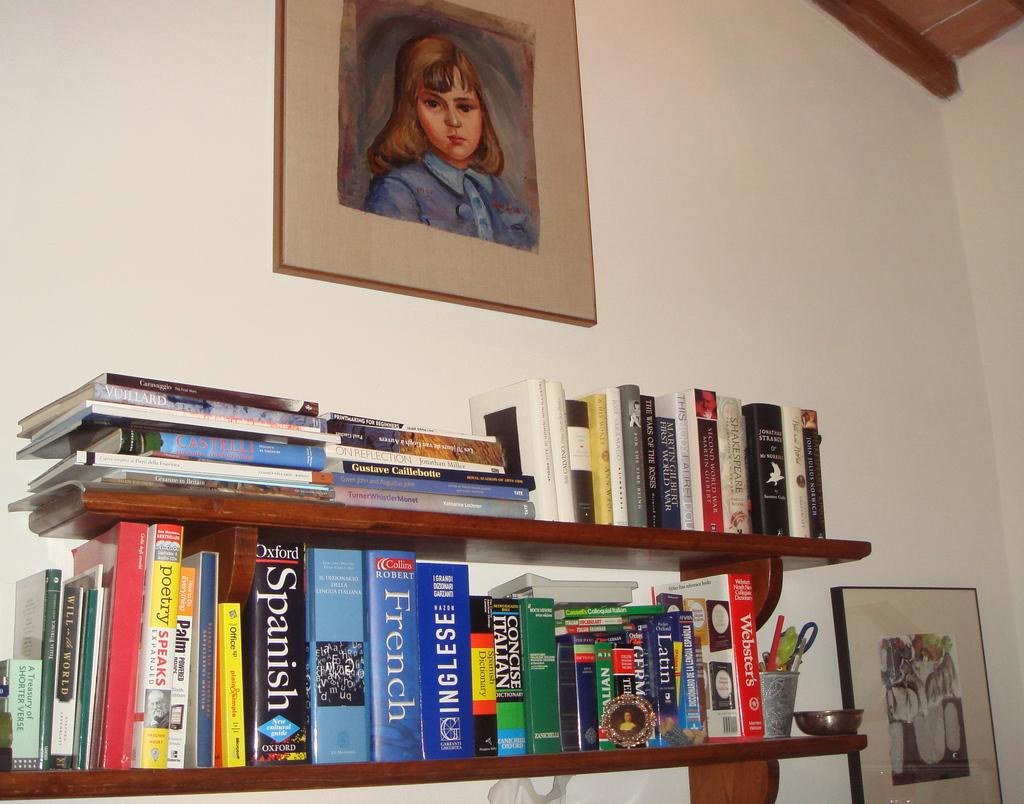What can be seen in the racks in the image? There are books in the racks in the image. What is attached to the wall in the background of the image? There are frames attached to the wall in the background of the image. What color is the wall in the image? The wall is white in color. What time of day is it in the image, considering the morning light? There is no indication of the time of day in the image, as the provided facts do not mention any lighting or time-related details. Can you tell me how many volleyballs are present in the image? There are no volleyballs present in the image; the facts mention books in racks and frames on the wall. What type of wrist accessory is visible on the person in the image? There is no person present in the image, as the facts mention books in racks and frames on the wall. 